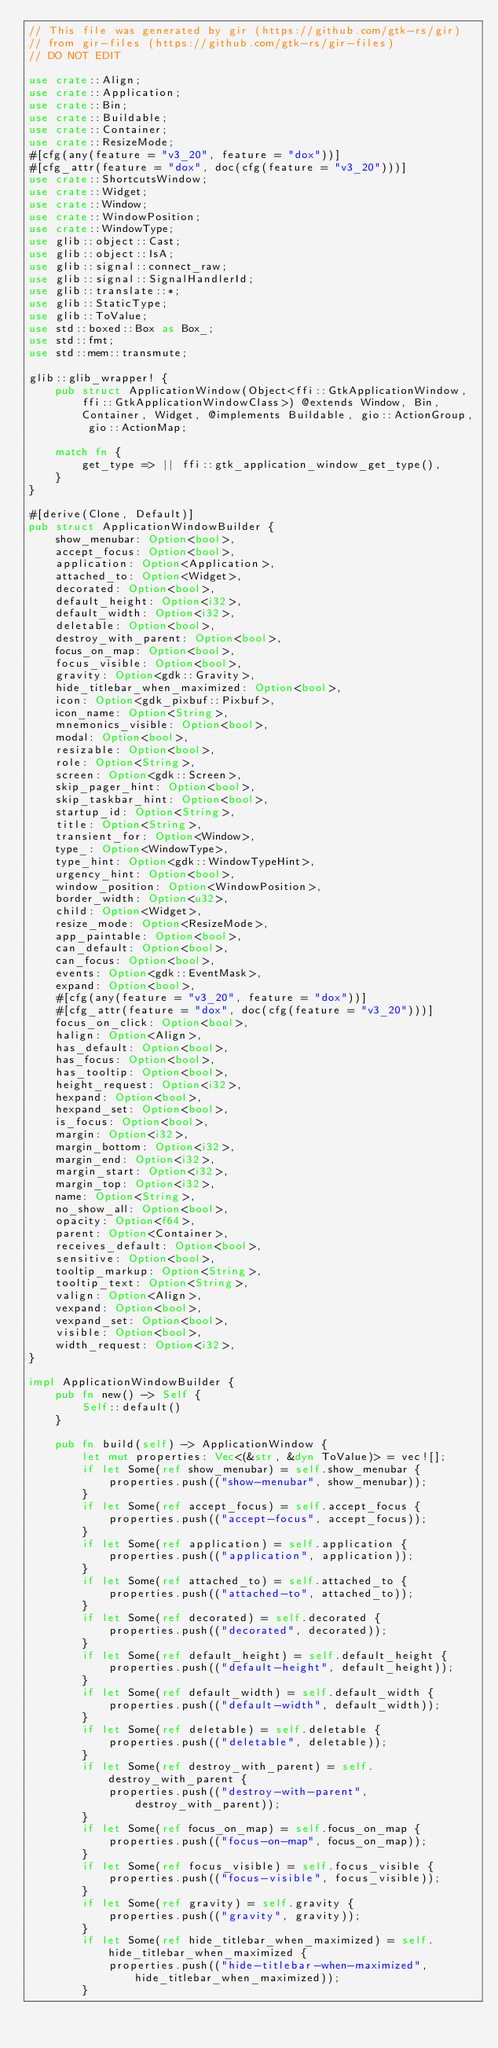Convert code to text. <code><loc_0><loc_0><loc_500><loc_500><_Rust_>// This file was generated by gir (https://github.com/gtk-rs/gir)
// from gir-files (https://github.com/gtk-rs/gir-files)
// DO NOT EDIT

use crate::Align;
use crate::Application;
use crate::Bin;
use crate::Buildable;
use crate::Container;
use crate::ResizeMode;
#[cfg(any(feature = "v3_20", feature = "dox"))]
#[cfg_attr(feature = "dox", doc(cfg(feature = "v3_20")))]
use crate::ShortcutsWindow;
use crate::Widget;
use crate::Window;
use crate::WindowPosition;
use crate::WindowType;
use glib::object::Cast;
use glib::object::IsA;
use glib::signal::connect_raw;
use glib::signal::SignalHandlerId;
use glib::translate::*;
use glib::StaticType;
use glib::ToValue;
use std::boxed::Box as Box_;
use std::fmt;
use std::mem::transmute;

glib::glib_wrapper! {
    pub struct ApplicationWindow(Object<ffi::GtkApplicationWindow, ffi::GtkApplicationWindowClass>) @extends Window, Bin, Container, Widget, @implements Buildable, gio::ActionGroup, gio::ActionMap;

    match fn {
        get_type => || ffi::gtk_application_window_get_type(),
    }
}

#[derive(Clone, Default)]
pub struct ApplicationWindowBuilder {
    show_menubar: Option<bool>,
    accept_focus: Option<bool>,
    application: Option<Application>,
    attached_to: Option<Widget>,
    decorated: Option<bool>,
    default_height: Option<i32>,
    default_width: Option<i32>,
    deletable: Option<bool>,
    destroy_with_parent: Option<bool>,
    focus_on_map: Option<bool>,
    focus_visible: Option<bool>,
    gravity: Option<gdk::Gravity>,
    hide_titlebar_when_maximized: Option<bool>,
    icon: Option<gdk_pixbuf::Pixbuf>,
    icon_name: Option<String>,
    mnemonics_visible: Option<bool>,
    modal: Option<bool>,
    resizable: Option<bool>,
    role: Option<String>,
    screen: Option<gdk::Screen>,
    skip_pager_hint: Option<bool>,
    skip_taskbar_hint: Option<bool>,
    startup_id: Option<String>,
    title: Option<String>,
    transient_for: Option<Window>,
    type_: Option<WindowType>,
    type_hint: Option<gdk::WindowTypeHint>,
    urgency_hint: Option<bool>,
    window_position: Option<WindowPosition>,
    border_width: Option<u32>,
    child: Option<Widget>,
    resize_mode: Option<ResizeMode>,
    app_paintable: Option<bool>,
    can_default: Option<bool>,
    can_focus: Option<bool>,
    events: Option<gdk::EventMask>,
    expand: Option<bool>,
    #[cfg(any(feature = "v3_20", feature = "dox"))]
    #[cfg_attr(feature = "dox", doc(cfg(feature = "v3_20")))]
    focus_on_click: Option<bool>,
    halign: Option<Align>,
    has_default: Option<bool>,
    has_focus: Option<bool>,
    has_tooltip: Option<bool>,
    height_request: Option<i32>,
    hexpand: Option<bool>,
    hexpand_set: Option<bool>,
    is_focus: Option<bool>,
    margin: Option<i32>,
    margin_bottom: Option<i32>,
    margin_end: Option<i32>,
    margin_start: Option<i32>,
    margin_top: Option<i32>,
    name: Option<String>,
    no_show_all: Option<bool>,
    opacity: Option<f64>,
    parent: Option<Container>,
    receives_default: Option<bool>,
    sensitive: Option<bool>,
    tooltip_markup: Option<String>,
    tooltip_text: Option<String>,
    valign: Option<Align>,
    vexpand: Option<bool>,
    vexpand_set: Option<bool>,
    visible: Option<bool>,
    width_request: Option<i32>,
}

impl ApplicationWindowBuilder {
    pub fn new() -> Self {
        Self::default()
    }

    pub fn build(self) -> ApplicationWindow {
        let mut properties: Vec<(&str, &dyn ToValue)> = vec![];
        if let Some(ref show_menubar) = self.show_menubar {
            properties.push(("show-menubar", show_menubar));
        }
        if let Some(ref accept_focus) = self.accept_focus {
            properties.push(("accept-focus", accept_focus));
        }
        if let Some(ref application) = self.application {
            properties.push(("application", application));
        }
        if let Some(ref attached_to) = self.attached_to {
            properties.push(("attached-to", attached_to));
        }
        if let Some(ref decorated) = self.decorated {
            properties.push(("decorated", decorated));
        }
        if let Some(ref default_height) = self.default_height {
            properties.push(("default-height", default_height));
        }
        if let Some(ref default_width) = self.default_width {
            properties.push(("default-width", default_width));
        }
        if let Some(ref deletable) = self.deletable {
            properties.push(("deletable", deletable));
        }
        if let Some(ref destroy_with_parent) = self.destroy_with_parent {
            properties.push(("destroy-with-parent", destroy_with_parent));
        }
        if let Some(ref focus_on_map) = self.focus_on_map {
            properties.push(("focus-on-map", focus_on_map));
        }
        if let Some(ref focus_visible) = self.focus_visible {
            properties.push(("focus-visible", focus_visible));
        }
        if let Some(ref gravity) = self.gravity {
            properties.push(("gravity", gravity));
        }
        if let Some(ref hide_titlebar_when_maximized) = self.hide_titlebar_when_maximized {
            properties.push(("hide-titlebar-when-maximized", hide_titlebar_when_maximized));
        }</code> 